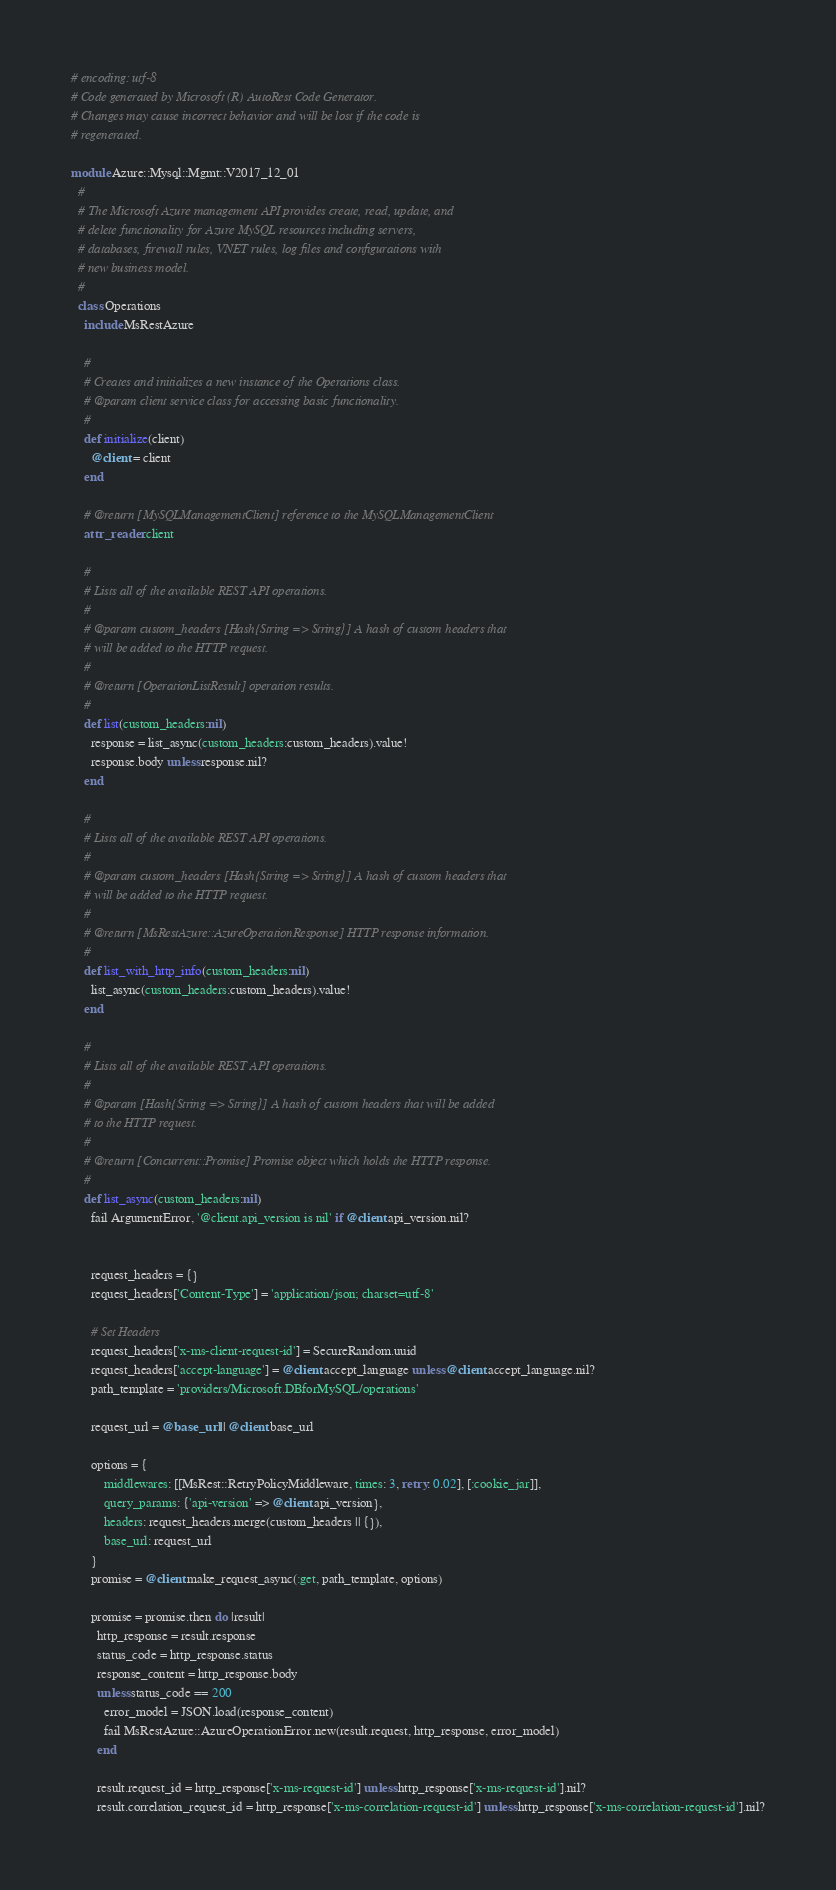Convert code to text. <code><loc_0><loc_0><loc_500><loc_500><_Ruby_># encoding: utf-8
# Code generated by Microsoft (R) AutoRest Code Generator.
# Changes may cause incorrect behavior and will be lost if the code is
# regenerated.

module Azure::Mysql::Mgmt::V2017_12_01
  #
  # The Microsoft Azure management API provides create, read, update, and
  # delete functionality for Azure MySQL resources including servers,
  # databases, firewall rules, VNET rules, log files and configurations with
  # new business model.
  #
  class Operations
    include MsRestAzure

    #
    # Creates and initializes a new instance of the Operations class.
    # @param client service class for accessing basic functionality.
    #
    def initialize(client)
      @client = client
    end

    # @return [MySQLManagementClient] reference to the MySQLManagementClient
    attr_reader :client

    #
    # Lists all of the available REST API operations.
    #
    # @param custom_headers [Hash{String => String}] A hash of custom headers that
    # will be added to the HTTP request.
    #
    # @return [OperationListResult] operation results.
    #
    def list(custom_headers:nil)
      response = list_async(custom_headers:custom_headers).value!
      response.body unless response.nil?
    end

    #
    # Lists all of the available REST API operations.
    #
    # @param custom_headers [Hash{String => String}] A hash of custom headers that
    # will be added to the HTTP request.
    #
    # @return [MsRestAzure::AzureOperationResponse] HTTP response information.
    #
    def list_with_http_info(custom_headers:nil)
      list_async(custom_headers:custom_headers).value!
    end

    #
    # Lists all of the available REST API operations.
    #
    # @param [Hash{String => String}] A hash of custom headers that will be added
    # to the HTTP request.
    #
    # @return [Concurrent::Promise] Promise object which holds the HTTP response.
    #
    def list_async(custom_headers:nil)
      fail ArgumentError, '@client.api_version is nil' if @client.api_version.nil?


      request_headers = {}
      request_headers['Content-Type'] = 'application/json; charset=utf-8'

      # Set Headers
      request_headers['x-ms-client-request-id'] = SecureRandom.uuid
      request_headers['accept-language'] = @client.accept_language unless @client.accept_language.nil?
      path_template = 'providers/Microsoft.DBforMySQL/operations'

      request_url = @base_url || @client.base_url

      options = {
          middlewares: [[MsRest::RetryPolicyMiddleware, times: 3, retry: 0.02], [:cookie_jar]],
          query_params: {'api-version' => @client.api_version},
          headers: request_headers.merge(custom_headers || {}),
          base_url: request_url
      }
      promise = @client.make_request_async(:get, path_template, options)

      promise = promise.then do |result|
        http_response = result.response
        status_code = http_response.status
        response_content = http_response.body
        unless status_code == 200
          error_model = JSON.load(response_content)
          fail MsRestAzure::AzureOperationError.new(result.request, http_response, error_model)
        end

        result.request_id = http_response['x-ms-request-id'] unless http_response['x-ms-request-id'].nil?
        result.correlation_request_id = http_response['x-ms-correlation-request-id'] unless http_response['x-ms-correlation-request-id'].nil?</code> 